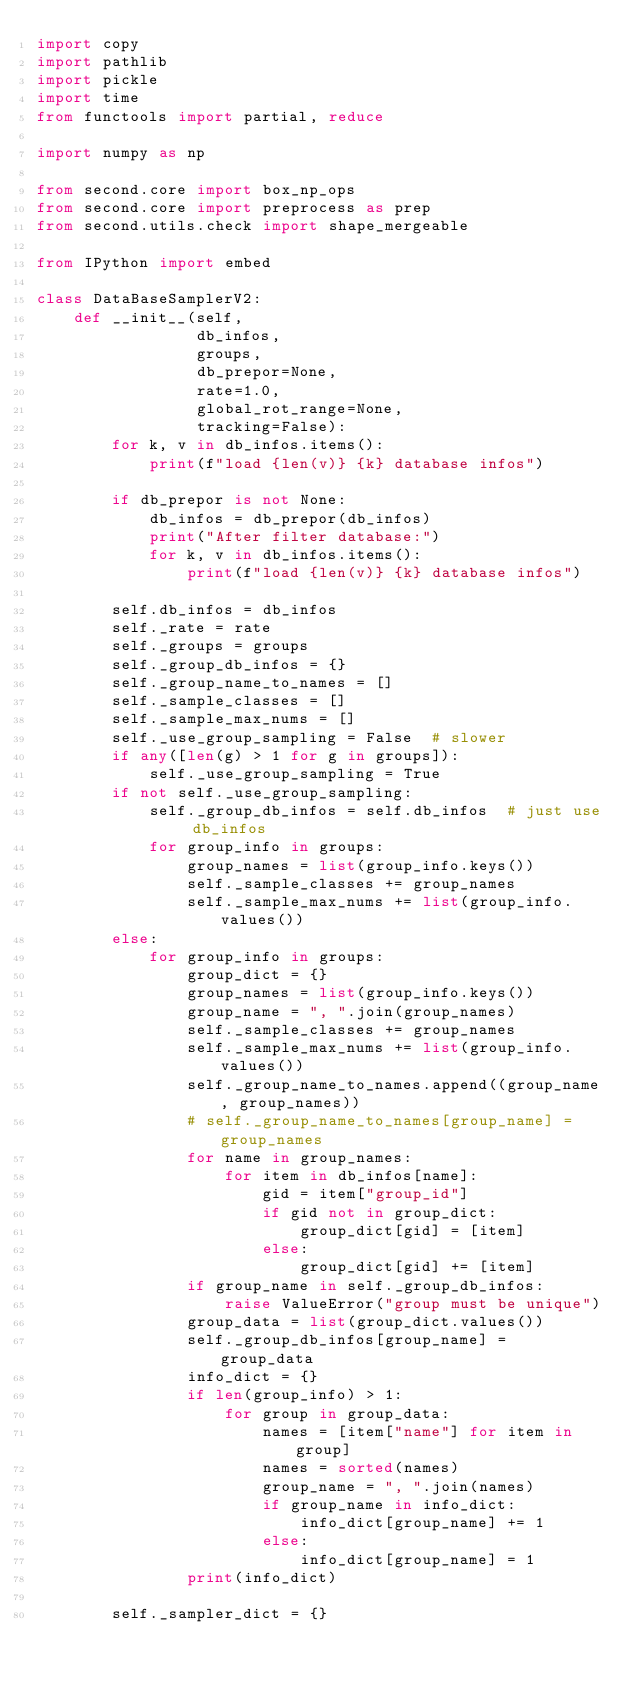<code> <loc_0><loc_0><loc_500><loc_500><_Python_>import copy
import pathlib
import pickle
import time
from functools import partial, reduce

import numpy as np

from second.core import box_np_ops
from second.core import preprocess as prep
from second.utils.check import shape_mergeable

from IPython import embed

class DataBaseSamplerV2:
    def __init__(self,
                 db_infos,
                 groups,
                 db_prepor=None,
                 rate=1.0,
                 global_rot_range=None,
                 tracking=False):
        for k, v in db_infos.items():
            print(f"load {len(v)} {k} database infos")

        if db_prepor is not None:
            db_infos = db_prepor(db_infos)
            print("After filter database:")
            for k, v in db_infos.items():
                print(f"load {len(v)} {k} database infos")

        self.db_infos = db_infos
        self._rate = rate
        self._groups = groups
        self._group_db_infos = {}
        self._group_name_to_names = []
        self._sample_classes = []
        self._sample_max_nums = []
        self._use_group_sampling = False  # slower
        if any([len(g) > 1 for g in groups]):
            self._use_group_sampling = True
        if not self._use_group_sampling:
            self._group_db_infos = self.db_infos  # just use db_infos
            for group_info in groups:
                group_names = list(group_info.keys())
                self._sample_classes += group_names
                self._sample_max_nums += list(group_info.values())
        else:
            for group_info in groups:
                group_dict = {}
                group_names = list(group_info.keys())
                group_name = ", ".join(group_names)
                self._sample_classes += group_names
                self._sample_max_nums += list(group_info.values())
                self._group_name_to_names.append((group_name, group_names))
                # self._group_name_to_names[group_name] = group_names
                for name in group_names:
                    for item in db_infos[name]:
                        gid = item["group_id"]
                        if gid not in group_dict:
                            group_dict[gid] = [item]
                        else:
                            group_dict[gid] += [item]
                if group_name in self._group_db_infos:
                    raise ValueError("group must be unique")
                group_data = list(group_dict.values())
                self._group_db_infos[group_name] = group_data
                info_dict = {}
                if len(group_info) > 1:
                    for group in group_data:
                        names = [item["name"] for item in group]
                        names = sorted(names)
                        group_name = ", ".join(names)
                        if group_name in info_dict:
                            info_dict[group_name] += 1
                        else:
                            info_dict[group_name] = 1
                print(info_dict)

        self._sampler_dict = {}</code> 